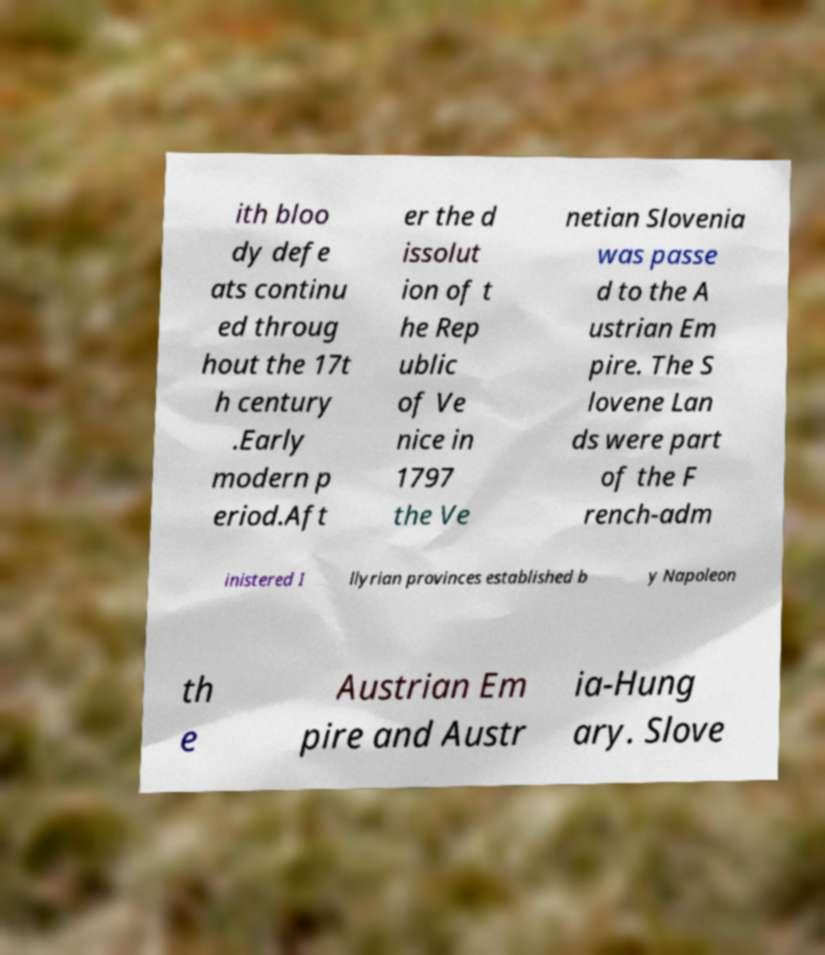For documentation purposes, I need the text within this image transcribed. Could you provide that? ith bloo dy defe ats continu ed throug hout the 17t h century .Early modern p eriod.Aft er the d issolut ion of t he Rep ublic of Ve nice in 1797 the Ve netian Slovenia was passe d to the A ustrian Em pire. The S lovene Lan ds were part of the F rench-adm inistered I llyrian provinces established b y Napoleon th e Austrian Em pire and Austr ia-Hung ary. Slove 